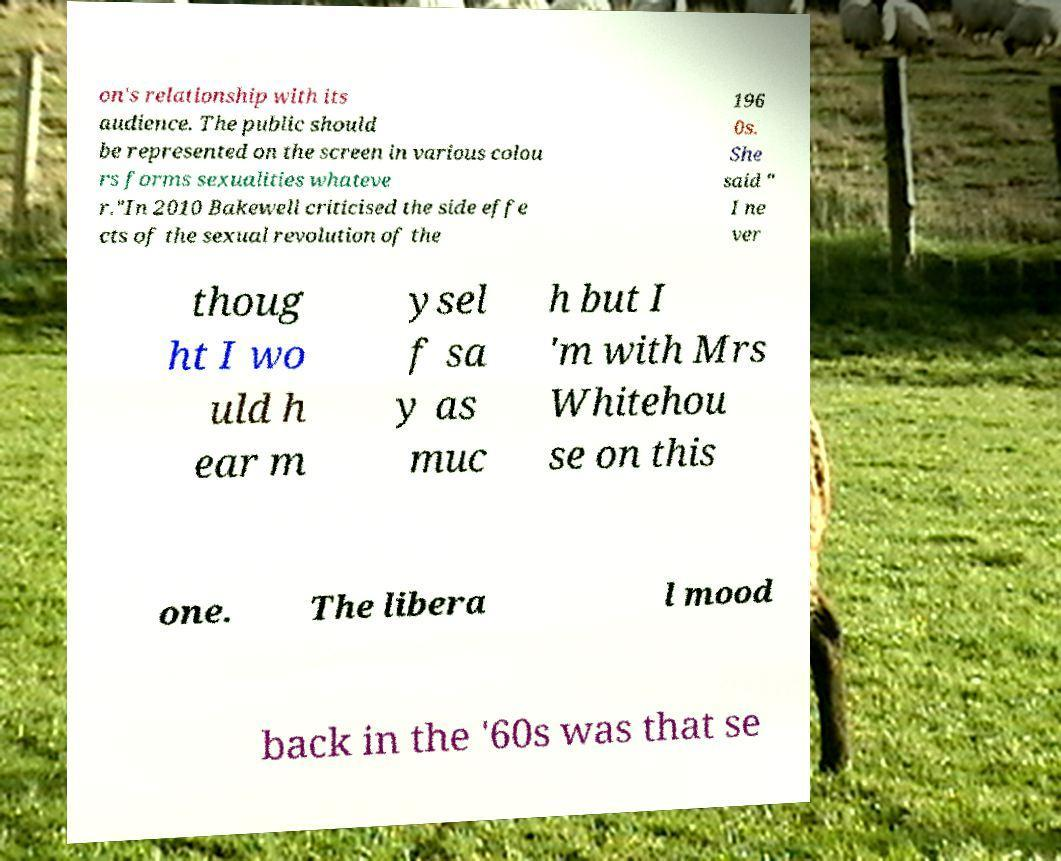Could you extract and type out the text from this image? on's relationship with its audience. The public should be represented on the screen in various colou rs forms sexualities whateve r."In 2010 Bakewell criticised the side effe cts of the sexual revolution of the 196 0s. She said " I ne ver thoug ht I wo uld h ear m ysel f sa y as muc h but I 'm with Mrs Whitehou se on this one. The libera l mood back in the '60s was that se 